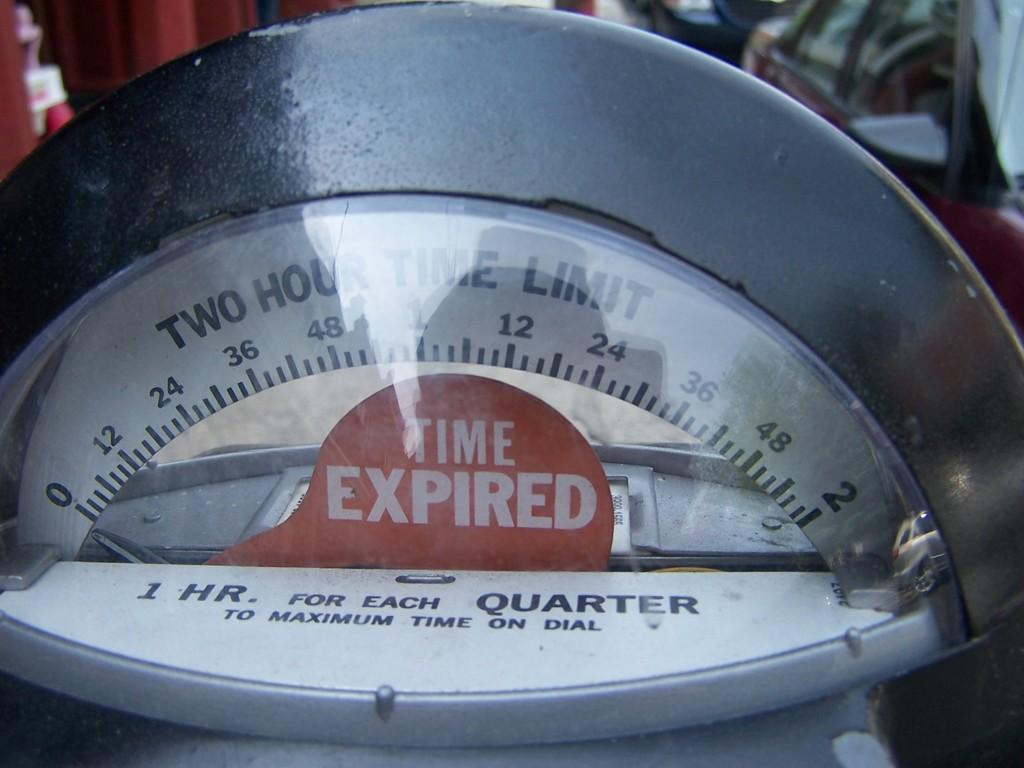<image>
Provide a brief description of the given image. a parking metter diplaying that time has expired 